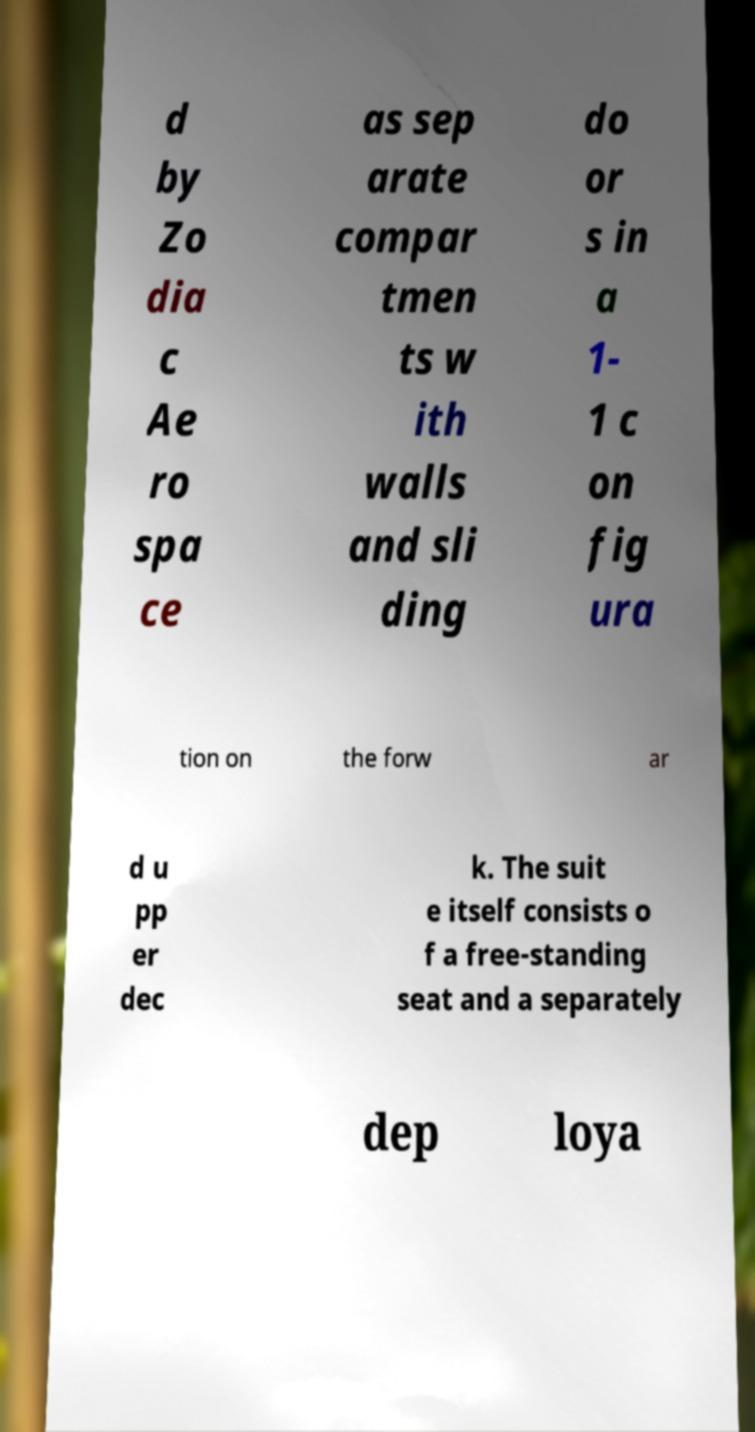For documentation purposes, I need the text within this image transcribed. Could you provide that? d by Zo dia c Ae ro spa ce as sep arate compar tmen ts w ith walls and sli ding do or s in a 1- 1 c on fig ura tion on the forw ar d u pp er dec k. The suit e itself consists o f a free-standing seat and a separately dep loya 